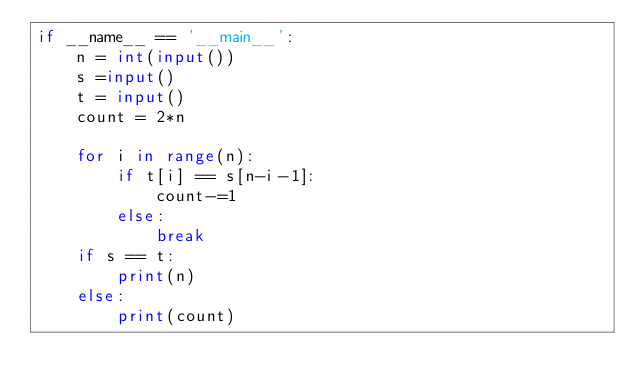Convert code to text. <code><loc_0><loc_0><loc_500><loc_500><_Python_>if __name__ == '__main__':
    n = int(input())
    s =input()
    t = input()
    count = 2*n

    for i in range(n):
        if t[i] == s[n-i-1]:
            count-=1
        else:
            break
    if s == t:
        print(n)
    else:
        print(count)</code> 